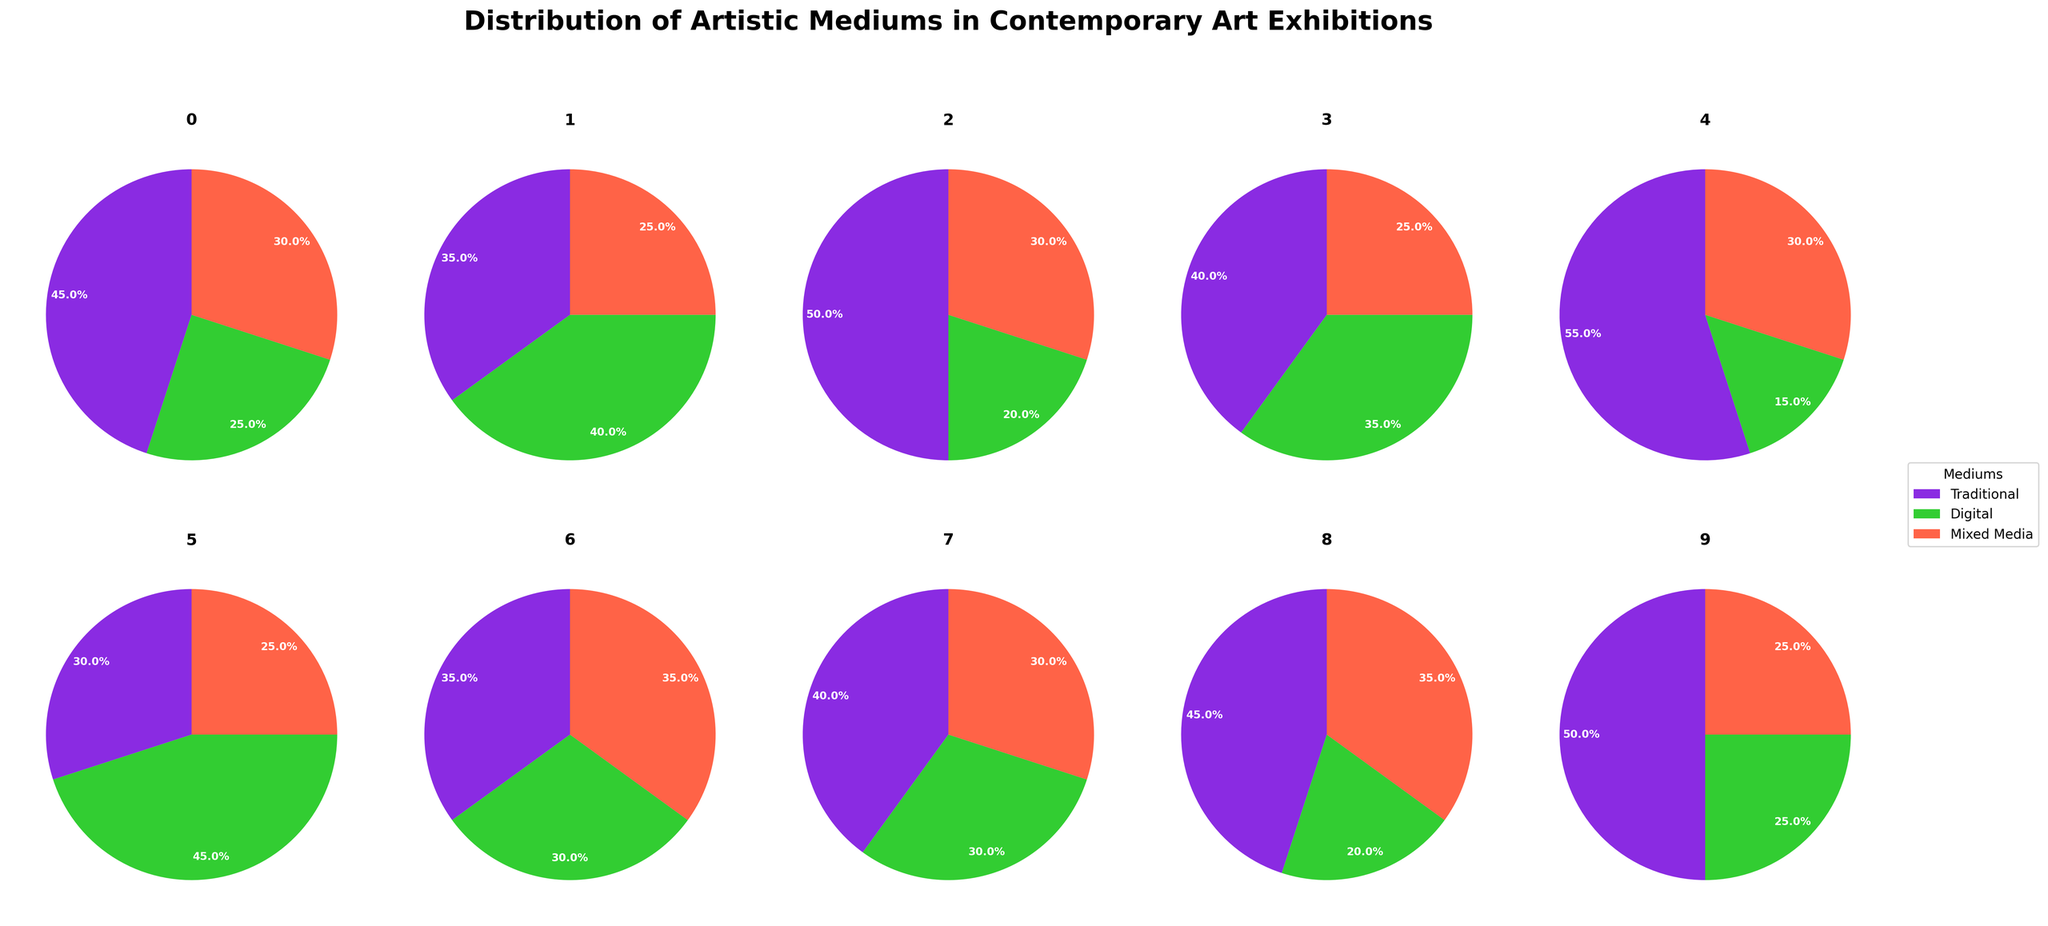What is the title of the figure? The title is prominently located at the top of the figure in large, bold font. It reads "Distribution of Artistic Mediums in Contemporary Art Exhibitions."
Answer: Distribution of Artistic Mediums in Contemporary Art Exhibitions Which exhibition has the highest proportion of Traditional medium artworks? To find this information, examine the sections of the pie charts that correspond to the Traditional medium, typically located in a specific color (e.g., purple). The exhibition with the largest section in this category is identified.
Answer: Frieze Art Fair In the Venice Biennale, what percentage of the artworks is represented by Digital medium? Locate the pie chart labeled Venice Biennale and identify the section corresponding to the Digital medium, which is detailed in a specific color (e.g., green). The percentage is directly shown within the pie section.
Answer: 25% Between Whitney Biennial and Tate Triennial, which exhibition features a greater proportion of Mixed Media artworks, and by how much? Compare the Mixed Media sections of the pie charts for both exhibitions. The Whitney Biennial shows 25% in this category, while the Tate Triennial also shows 25%. Therefore, the proportion is equal.
Answer: Equal, 0% What is the combined percentage of Digital Medium artworks in the Documenta and Gwangju Biennale exhibitions? Locate the pie charts for Documenta and Gwangju Biennale, identify the Digital medium sections, and sum their percentages (Documenta: 40%, Gwangju Biennale: 30%). Thus, the combined percentage is 40% + 30% = 70%.
Answer: 70% Which exhibition has the smallest proportion of Digital medium artworks? Examine the digital medium sections across all pie charts. The smallest section is found in the Frieze Art Fair, which has 15% allocated to Digital medium.
Answer: Frieze Art Fair In the Art Basel exhibition, what is the difference in percentage points between Traditional and Mixed Media artworks? Locate the Art Basel pie chart, examine the segments for Traditional (50%) and Mixed Media (30%), and calculate the difference: 50% - 30% = 20 percentage points.
Answer: 20 percentage points Across all exhibitions, which medium appears to be the most prevalently represented? Summarize the sections of each medium across all pie charts, looking for the medium that consistently has the largest portions. Traditional appears frequently as the largest section.
Answer: Traditional What is the percentage of Mixed Media artworks in the Sharjah Biennial? In the pie chart corresponding to the Sharjah Biennial, locate the section colored for Mixed Media. The percentage is annotated within the pie section.
Answer: 35% Which exhibition features the most balanced distribution between all three artistic mediums? Observe all the pie charts and assess which has the most even sections for Traditional, Digital, and Mixed Media. Manifesta, with close proportions of 35%, 30%, and 35%, respectively, appears most balanced.
Answer: Manifesta 